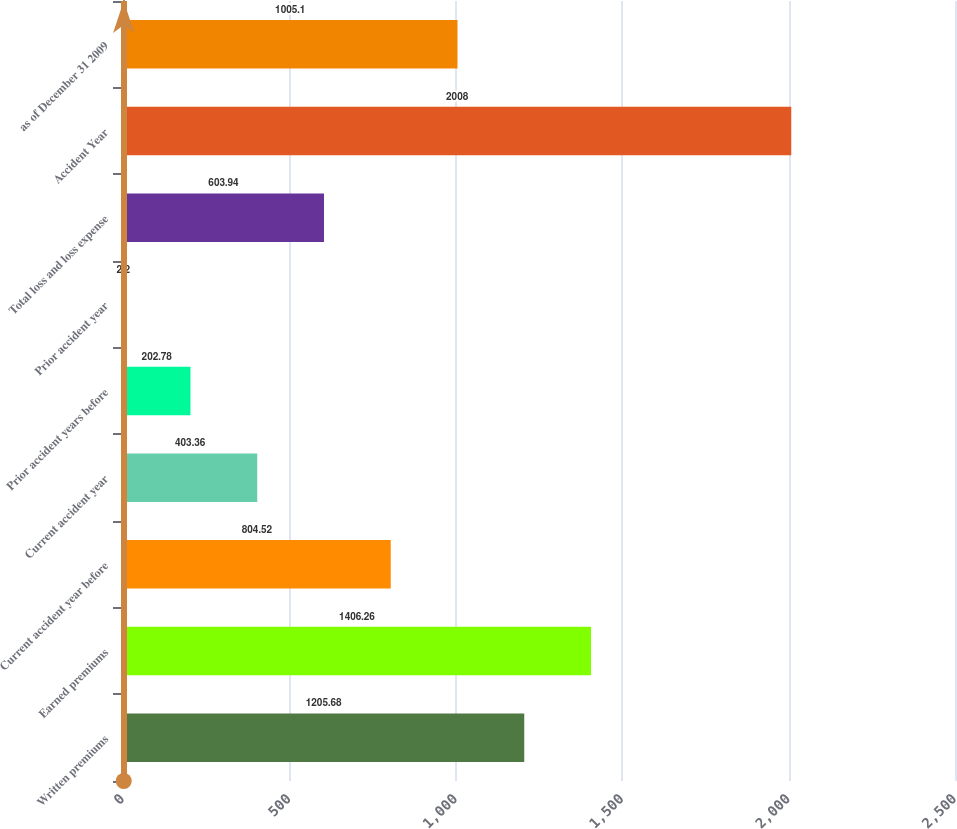Convert chart to OTSL. <chart><loc_0><loc_0><loc_500><loc_500><bar_chart><fcel>Written premiums<fcel>Earned premiums<fcel>Current accident year before<fcel>Current accident year<fcel>Prior accident years before<fcel>Prior accident year<fcel>Total loss and loss expense<fcel>Accident Year<fcel>as of December 31 2009<nl><fcel>1205.68<fcel>1406.26<fcel>804.52<fcel>403.36<fcel>202.78<fcel>2.2<fcel>603.94<fcel>2008<fcel>1005.1<nl></chart> 